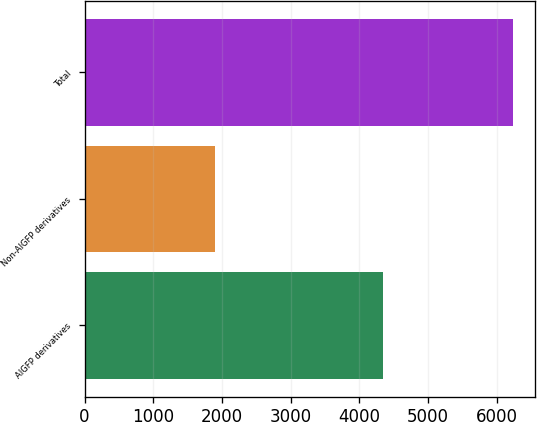Convert chart to OTSL. <chart><loc_0><loc_0><loc_500><loc_500><bar_chart><fcel>AIGFP derivatives<fcel>Non-AIGFP derivatives<fcel>Total<nl><fcel>4344<fcel>1894<fcel>6238<nl></chart> 